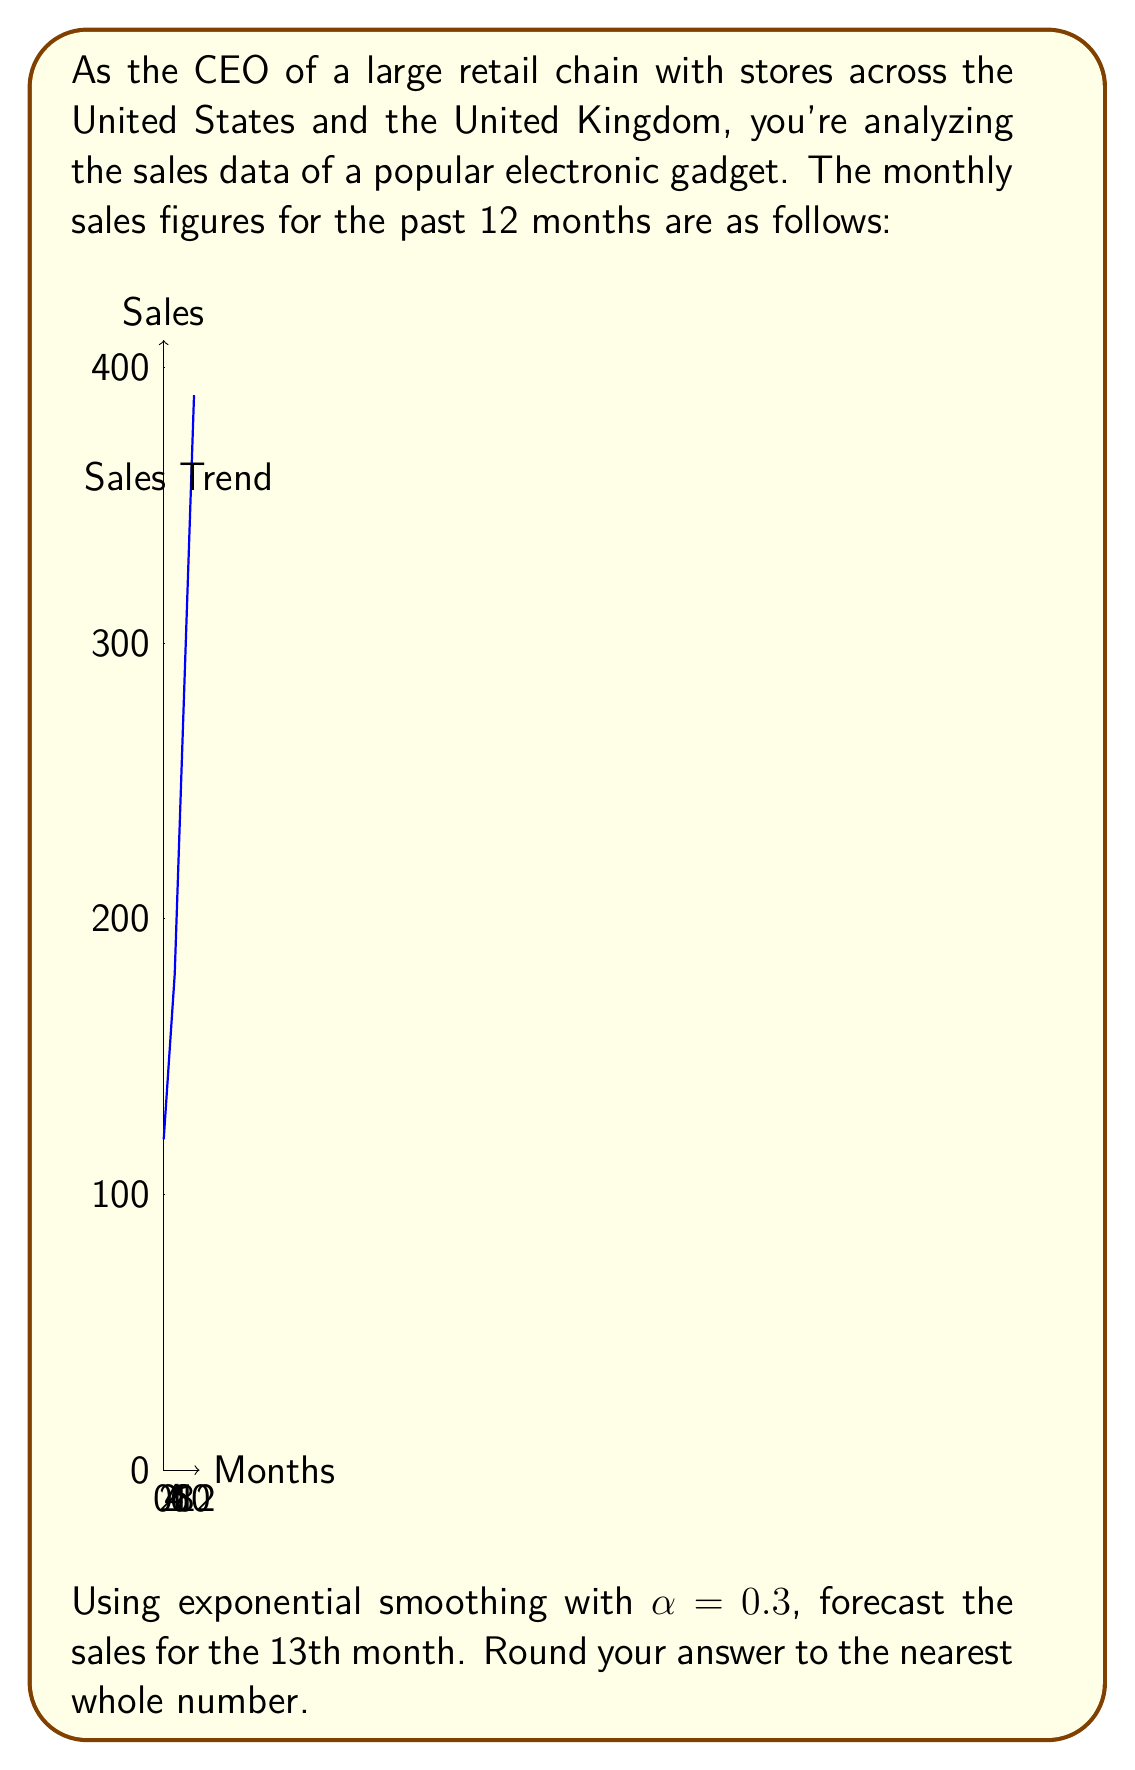Provide a solution to this math problem. To solve this problem using exponential smoothing, we'll follow these steps:

1) The exponential smoothing formula is:
   $$F_{t+1} = \alpha Y_t + (1-\alpha)F_t$$
   Where:
   $F_{t+1}$ is the forecast for the next period
   $\alpha$ is the smoothing factor (0.3 in this case)
   $Y_t$ is the actual value at time t
   $F_t$ is the forecast for the current period

2) We need to initialize $F_1$. A common method is to use the first actual value. So, $F_1 = 120$.

3) Now we can calculate the forecasts for each period:

   $F_2 = 0.3(120) + 0.7(120) = 120$
   $F_3 = 0.3(135) + 0.7(120) = 124.5$
   $F_4 = 0.3(150) + 0.7(124.5) = 132.15$
   ...

4) We continue this process for all 12 months. The forecast for the 12th month will be:

   $F_{12} = 0.3(360) + 0.7(269.56) = 296.69$

5) Finally, we can forecast the 13th month:

   $F_{13} = 0.3(390) + 0.7(296.69) = 324.68$

6) Rounding to the nearest whole number: 325
Answer: 325 